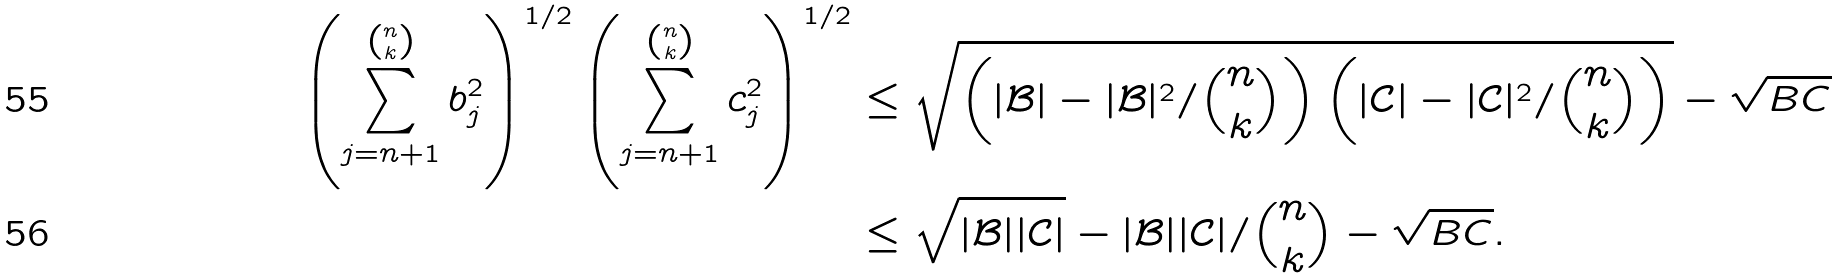<formula> <loc_0><loc_0><loc_500><loc_500>\left ( \sum _ { j = n + 1 } ^ { n \choose k } b _ { j } ^ { 2 } \right ) ^ { 1 / 2 } \left ( \sum _ { j = n + 1 } ^ { n \choose k } c _ { j } ^ { 2 } \right ) ^ { 1 / 2 } & \leq \sqrt { \left ( | \mathcal { B } | - | \mathcal { B } | ^ { 2 } / \binom { n } { k } \right ) \left ( | \mathcal { C } | - | \mathcal { C } | ^ { 2 } / \binom { n } { k } \right ) } - \sqrt { B C } \\ & \leq \sqrt { | \mathcal { B } | | \mathcal { C } | } - | \mathcal { B } | | \mathcal { C } | / \binom { n } { k } - \sqrt { B C } .</formula> 